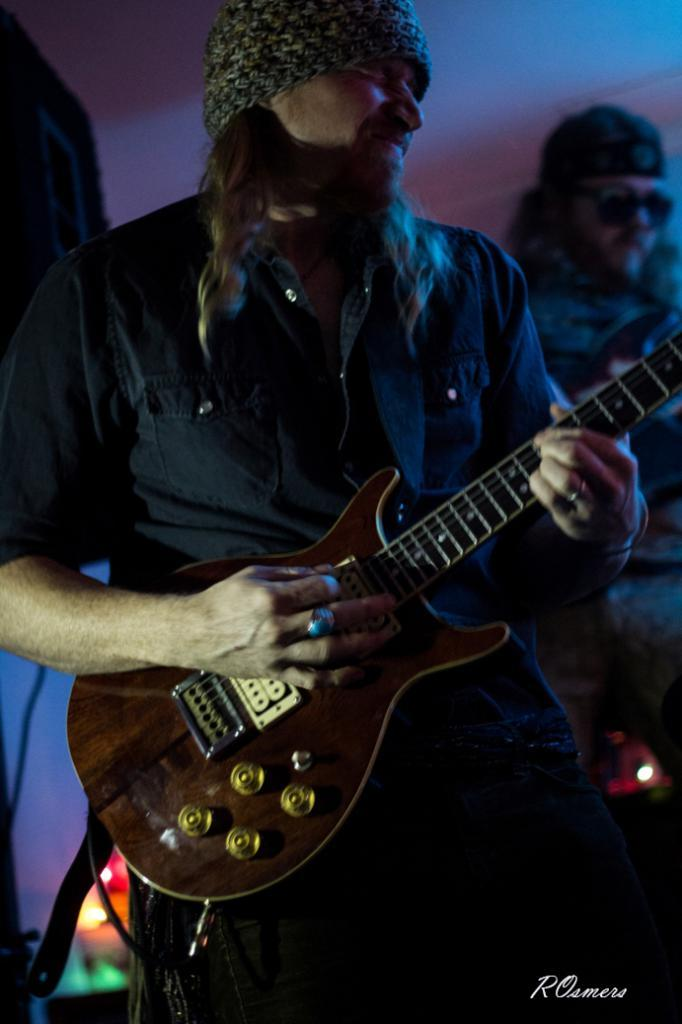Who is the main subject in the image? There is a man in the image. Where is the man located in the image? The man is at the center of the image. What is the man holding in the image? The man is holding a guitar. How is the guitar being held by the man? The guitar is in his hands. What type of headwear is the man wearing? The man is wearing a cap. How is the cap positioned on the man's head? The cap is over his head. How many visitors can be seen in the image? There are no visitors present in the image; it only features a man holding a guitar. What type of pot is being used by the man to play the guitar? There is no pot present in the image, and the man is not using any pot to play the guitar. 